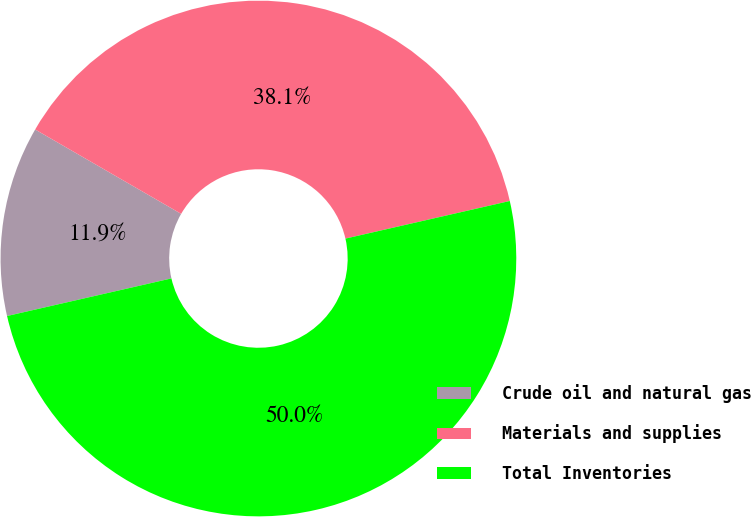<chart> <loc_0><loc_0><loc_500><loc_500><pie_chart><fcel>Crude oil and natural gas<fcel>Materials and supplies<fcel>Total Inventories<nl><fcel>11.92%<fcel>38.08%<fcel>50.0%<nl></chart> 